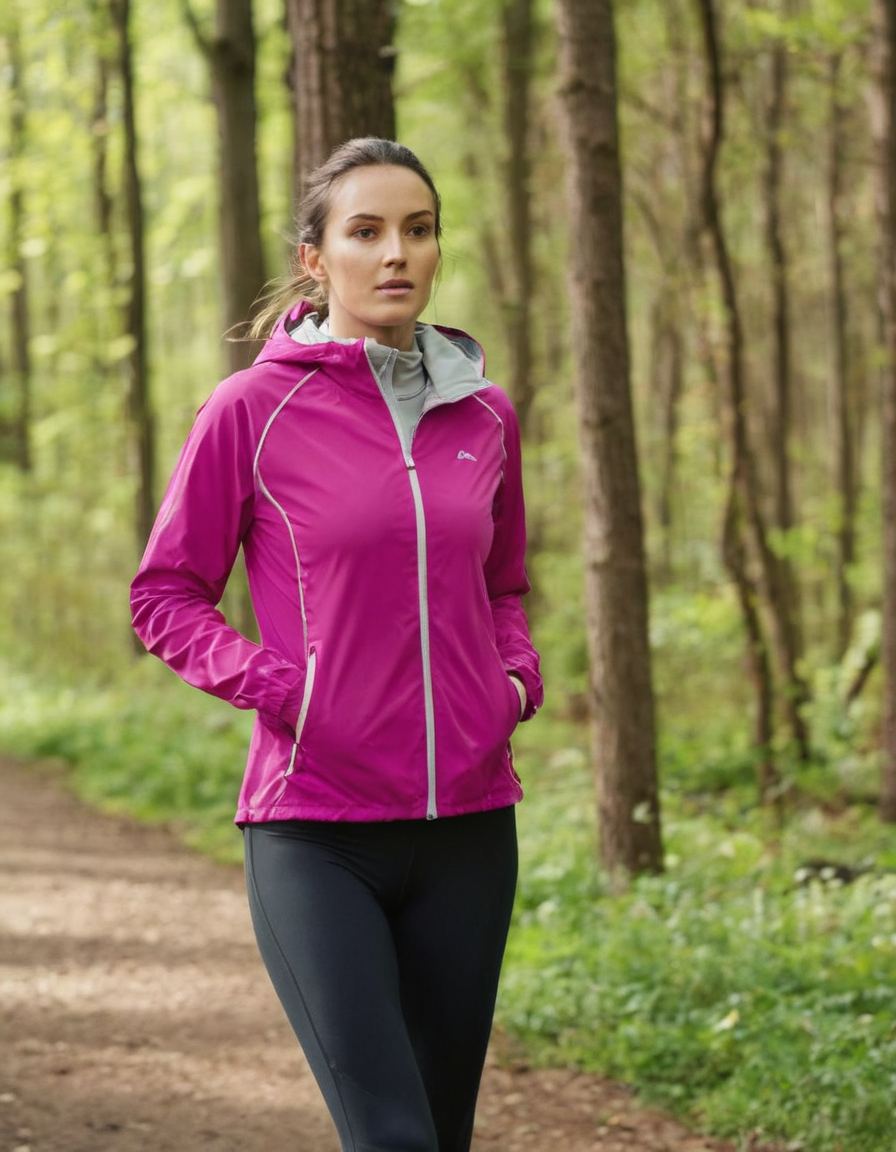Is the following image artificially (AI) generated? Explain your reasoning. It is difficult to say for certain whether the image is AI-generated without more information.  However, here are some points to consider:

* **High quality:** The image has good resolution and details, which is typical of real photos. 
* **Natural elements:**  The trees, foliage, and lighting all appear natural, making it less likely to be AI generated.
* **Human subject:** While AI image generation is improving, creating realistic human figures with natural poses and expressions is still challenging. The subject's pose, facial features, and overall appearance look natural.

**Without additional clues or comparing the image to known AI-generated results, it is difficult to definitively say if the image was AI generated.**  If you have further information about the image's origin or if you suspect it might be AI-generated, provide that information for a more informed analysis. 